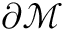Convert formula to latex. <formula><loc_0><loc_0><loc_500><loc_500>\partial \mathcal { M }</formula> 